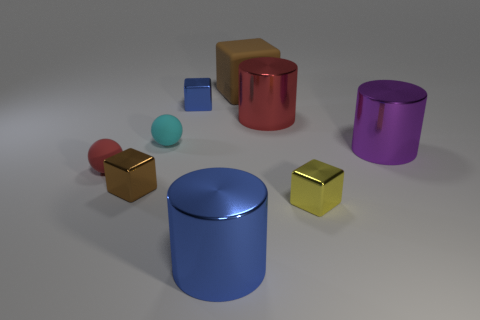Add 1 small yellow metal objects. How many objects exist? 10 Subtract all spheres. How many objects are left? 7 Subtract all large cyan cubes. Subtract all large cubes. How many objects are left? 8 Add 6 big things. How many big things are left? 10 Add 6 small brown objects. How many small brown objects exist? 7 Subtract 1 red cylinders. How many objects are left? 8 